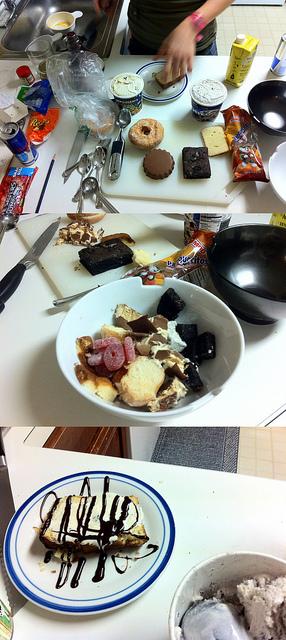What is drizzled over the plate in the bottom left?
Write a very short answer. Chocolate. Which picture has a person's hand in it?
Write a very short answer. Top. What course would these three things be eaten for?
Keep it brief. Dessert. 